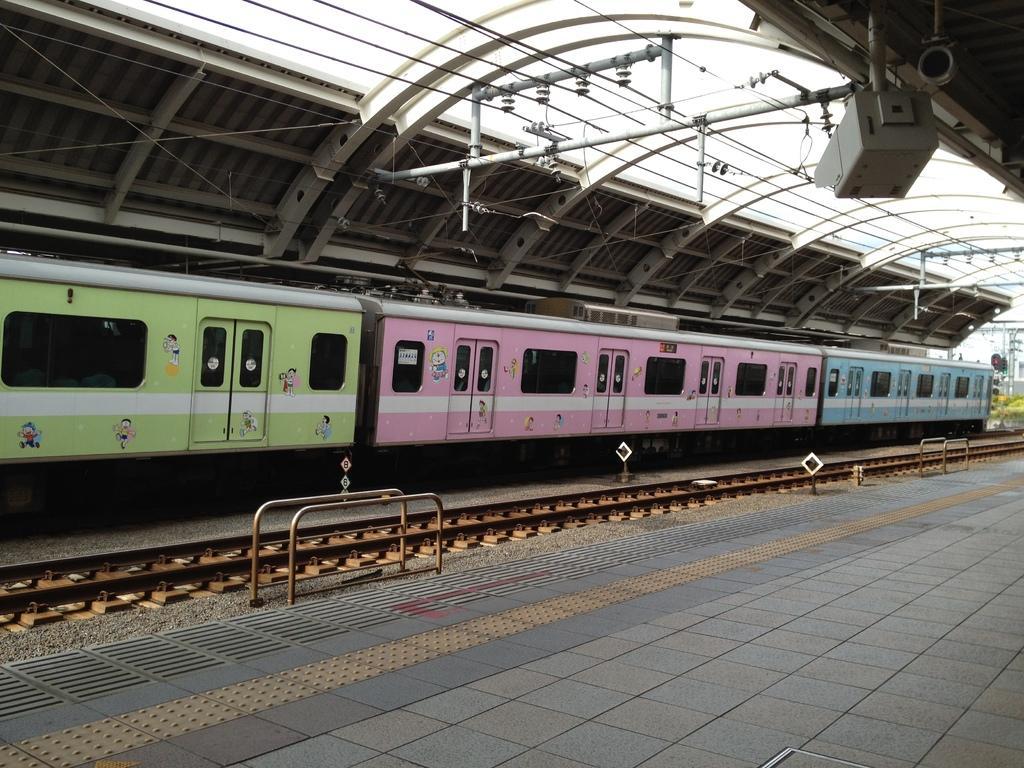How would you summarize this image in a sentence or two? This is the picture of a train on the train track and around there are some poles, grills and some wires to the roof. 